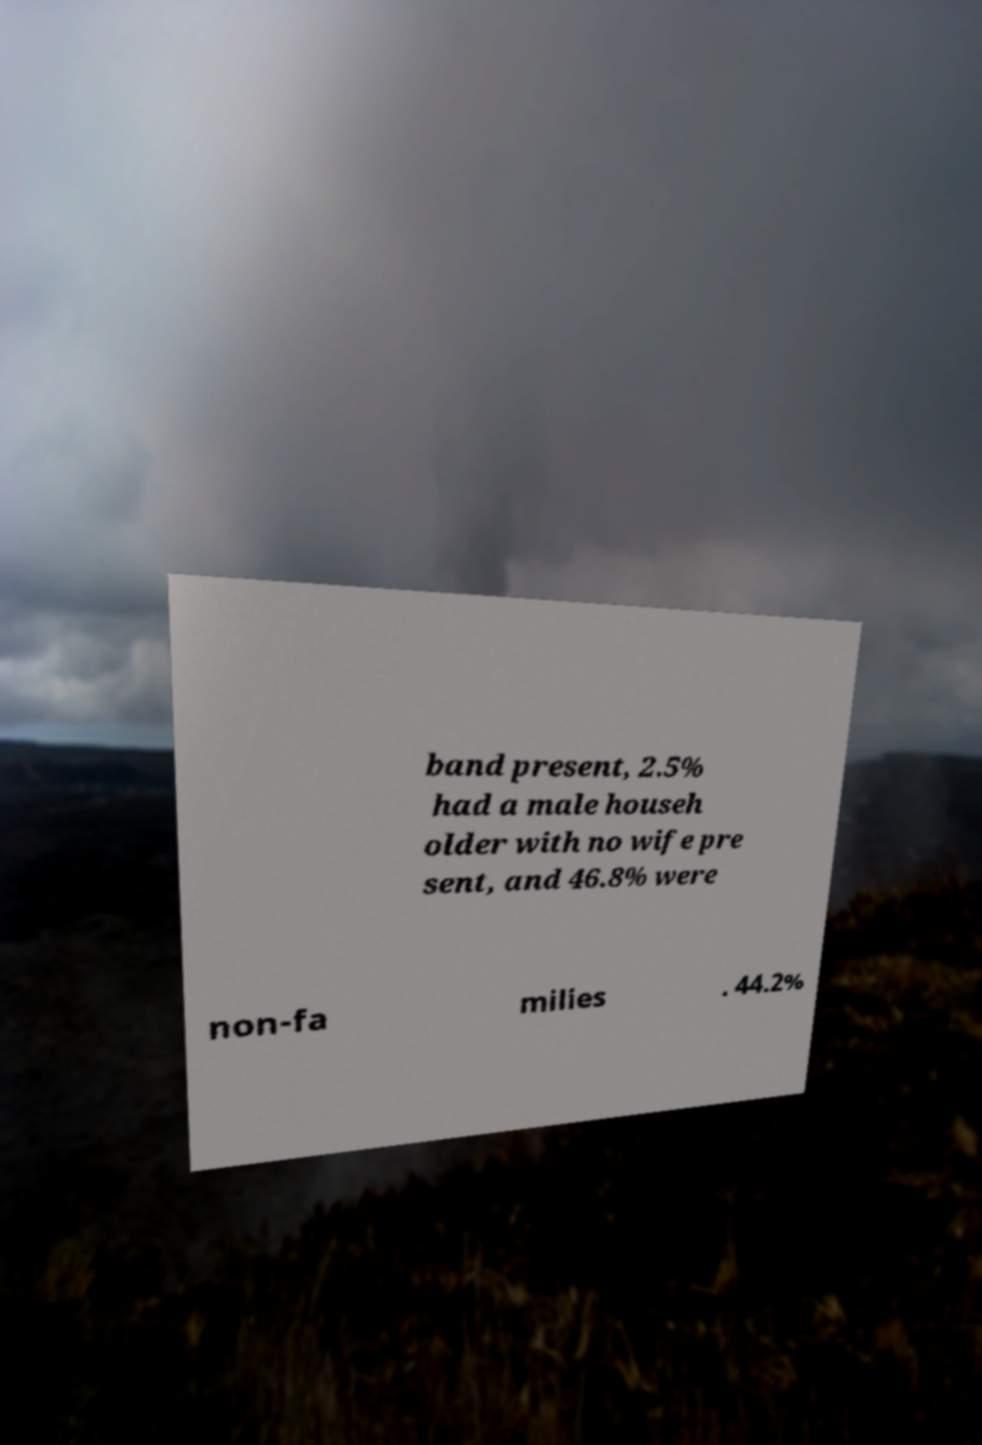Could you assist in decoding the text presented in this image and type it out clearly? band present, 2.5% had a male househ older with no wife pre sent, and 46.8% were non-fa milies . 44.2% 